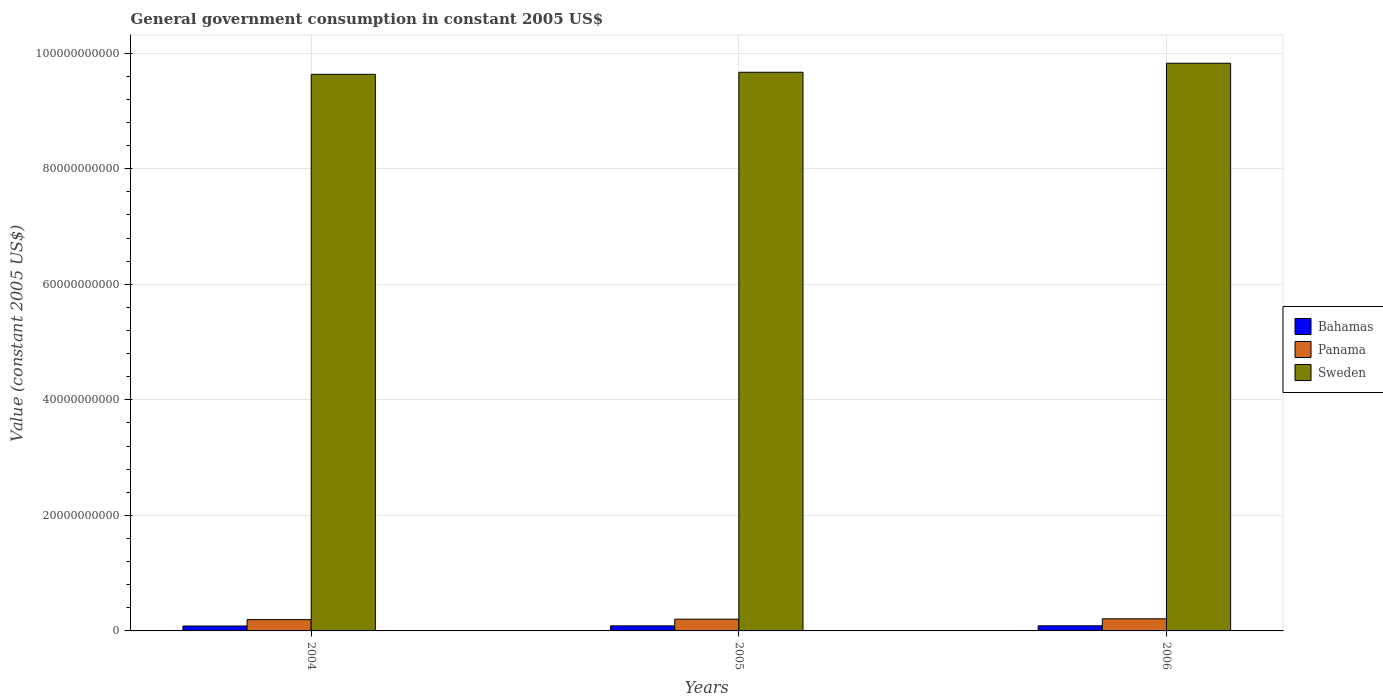How many different coloured bars are there?
Ensure brevity in your answer.  3. How many groups of bars are there?
Make the answer very short. 3. Are the number of bars on each tick of the X-axis equal?
Your answer should be compact. Yes. In how many cases, is the number of bars for a given year not equal to the number of legend labels?
Offer a very short reply. 0. What is the government conusmption in Bahamas in 2004?
Offer a terse response. 8.47e+08. Across all years, what is the maximum government conusmption in Bahamas?
Offer a terse response. 8.88e+08. Across all years, what is the minimum government conusmption in Sweden?
Provide a short and direct response. 9.63e+1. In which year was the government conusmption in Panama minimum?
Ensure brevity in your answer.  2004. What is the total government conusmption in Bahamas in the graph?
Your response must be concise. 2.61e+09. What is the difference between the government conusmption in Sweden in 2004 and that in 2005?
Keep it short and to the point. -3.58e+08. What is the difference between the government conusmption in Bahamas in 2006 and the government conusmption in Sweden in 2004?
Make the answer very short. -9.55e+1. What is the average government conusmption in Panama per year?
Your response must be concise. 2.03e+09. In the year 2005, what is the difference between the government conusmption in Sweden and government conusmption in Panama?
Give a very brief answer. 9.47e+1. In how many years, is the government conusmption in Bahamas greater than 20000000000 US$?
Offer a terse response. 0. What is the ratio of the government conusmption in Panama in 2005 to that in 2006?
Offer a terse response. 0.97. What is the difference between the highest and the second highest government conusmption in Bahamas?
Provide a short and direct response. 1.53e+07. What is the difference between the highest and the lowest government conusmption in Sweden?
Your answer should be compact. 1.92e+09. In how many years, is the government conusmption in Bahamas greater than the average government conusmption in Bahamas taken over all years?
Provide a short and direct response. 2. Is the sum of the government conusmption in Bahamas in 2005 and 2006 greater than the maximum government conusmption in Panama across all years?
Offer a terse response. No. What does the 2nd bar from the right in 2006 represents?
Make the answer very short. Panama. Is it the case that in every year, the sum of the government conusmption in Sweden and government conusmption in Bahamas is greater than the government conusmption in Panama?
Offer a terse response. Yes. How many bars are there?
Give a very brief answer. 9. How many years are there in the graph?
Make the answer very short. 3. Does the graph contain any zero values?
Your answer should be very brief. No. How many legend labels are there?
Ensure brevity in your answer.  3. What is the title of the graph?
Your answer should be compact. General government consumption in constant 2005 US$. Does "Austria" appear as one of the legend labels in the graph?
Keep it short and to the point. No. What is the label or title of the X-axis?
Ensure brevity in your answer.  Years. What is the label or title of the Y-axis?
Your answer should be compact. Value (constant 2005 US$). What is the Value (constant 2005 US$) of Bahamas in 2004?
Give a very brief answer. 8.47e+08. What is the Value (constant 2005 US$) of Panama in 2004?
Make the answer very short. 1.95e+09. What is the Value (constant 2005 US$) of Sweden in 2004?
Make the answer very short. 9.63e+1. What is the Value (constant 2005 US$) of Bahamas in 2005?
Give a very brief answer. 8.73e+08. What is the Value (constant 2005 US$) of Panama in 2005?
Your answer should be compact. 2.03e+09. What is the Value (constant 2005 US$) of Sweden in 2005?
Your answer should be compact. 9.67e+1. What is the Value (constant 2005 US$) in Bahamas in 2006?
Provide a succinct answer. 8.88e+08. What is the Value (constant 2005 US$) of Panama in 2006?
Make the answer very short. 2.10e+09. What is the Value (constant 2005 US$) in Sweden in 2006?
Ensure brevity in your answer.  9.83e+1. Across all years, what is the maximum Value (constant 2005 US$) in Bahamas?
Your answer should be very brief. 8.88e+08. Across all years, what is the maximum Value (constant 2005 US$) of Panama?
Your answer should be very brief. 2.10e+09. Across all years, what is the maximum Value (constant 2005 US$) of Sweden?
Give a very brief answer. 9.83e+1. Across all years, what is the minimum Value (constant 2005 US$) of Bahamas?
Your answer should be compact. 8.47e+08. Across all years, what is the minimum Value (constant 2005 US$) of Panama?
Offer a very short reply. 1.95e+09. Across all years, what is the minimum Value (constant 2005 US$) in Sweden?
Make the answer very short. 9.63e+1. What is the total Value (constant 2005 US$) of Bahamas in the graph?
Provide a succinct answer. 2.61e+09. What is the total Value (constant 2005 US$) in Panama in the graph?
Offer a terse response. 6.08e+09. What is the total Value (constant 2005 US$) in Sweden in the graph?
Give a very brief answer. 2.91e+11. What is the difference between the Value (constant 2005 US$) in Bahamas in 2004 and that in 2005?
Ensure brevity in your answer.  -2.65e+07. What is the difference between the Value (constant 2005 US$) of Panama in 2004 and that in 2005?
Give a very brief answer. -8.10e+07. What is the difference between the Value (constant 2005 US$) of Sweden in 2004 and that in 2005?
Make the answer very short. -3.58e+08. What is the difference between the Value (constant 2005 US$) of Bahamas in 2004 and that in 2006?
Your response must be concise. -4.18e+07. What is the difference between the Value (constant 2005 US$) in Panama in 2004 and that in 2006?
Make the answer very short. -1.44e+08. What is the difference between the Value (constant 2005 US$) of Sweden in 2004 and that in 2006?
Provide a succinct answer. -1.92e+09. What is the difference between the Value (constant 2005 US$) in Bahamas in 2005 and that in 2006?
Make the answer very short. -1.53e+07. What is the difference between the Value (constant 2005 US$) in Panama in 2005 and that in 2006?
Make the answer very short. -6.29e+07. What is the difference between the Value (constant 2005 US$) of Sweden in 2005 and that in 2006?
Your answer should be compact. -1.56e+09. What is the difference between the Value (constant 2005 US$) of Bahamas in 2004 and the Value (constant 2005 US$) of Panama in 2005?
Offer a terse response. -1.19e+09. What is the difference between the Value (constant 2005 US$) of Bahamas in 2004 and the Value (constant 2005 US$) of Sweden in 2005?
Offer a terse response. -9.59e+1. What is the difference between the Value (constant 2005 US$) of Panama in 2004 and the Value (constant 2005 US$) of Sweden in 2005?
Make the answer very short. -9.47e+1. What is the difference between the Value (constant 2005 US$) in Bahamas in 2004 and the Value (constant 2005 US$) in Panama in 2006?
Give a very brief answer. -1.25e+09. What is the difference between the Value (constant 2005 US$) in Bahamas in 2004 and the Value (constant 2005 US$) in Sweden in 2006?
Provide a short and direct response. -9.74e+1. What is the difference between the Value (constant 2005 US$) in Panama in 2004 and the Value (constant 2005 US$) in Sweden in 2006?
Your response must be concise. -9.63e+1. What is the difference between the Value (constant 2005 US$) of Bahamas in 2005 and the Value (constant 2005 US$) of Panama in 2006?
Ensure brevity in your answer.  -1.22e+09. What is the difference between the Value (constant 2005 US$) in Bahamas in 2005 and the Value (constant 2005 US$) in Sweden in 2006?
Make the answer very short. -9.74e+1. What is the difference between the Value (constant 2005 US$) in Panama in 2005 and the Value (constant 2005 US$) in Sweden in 2006?
Offer a terse response. -9.62e+1. What is the average Value (constant 2005 US$) in Bahamas per year?
Offer a terse response. 8.69e+08. What is the average Value (constant 2005 US$) in Panama per year?
Your answer should be very brief. 2.03e+09. What is the average Value (constant 2005 US$) in Sweden per year?
Provide a short and direct response. 9.71e+1. In the year 2004, what is the difference between the Value (constant 2005 US$) of Bahamas and Value (constant 2005 US$) of Panama?
Ensure brevity in your answer.  -1.11e+09. In the year 2004, what is the difference between the Value (constant 2005 US$) of Bahamas and Value (constant 2005 US$) of Sweden?
Keep it short and to the point. -9.55e+1. In the year 2004, what is the difference between the Value (constant 2005 US$) of Panama and Value (constant 2005 US$) of Sweden?
Make the answer very short. -9.44e+1. In the year 2005, what is the difference between the Value (constant 2005 US$) in Bahamas and Value (constant 2005 US$) in Panama?
Provide a short and direct response. -1.16e+09. In the year 2005, what is the difference between the Value (constant 2005 US$) of Bahamas and Value (constant 2005 US$) of Sweden?
Offer a very short reply. -9.58e+1. In the year 2005, what is the difference between the Value (constant 2005 US$) in Panama and Value (constant 2005 US$) in Sweden?
Provide a short and direct response. -9.47e+1. In the year 2006, what is the difference between the Value (constant 2005 US$) of Bahamas and Value (constant 2005 US$) of Panama?
Offer a very short reply. -1.21e+09. In the year 2006, what is the difference between the Value (constant 2005 US$) in Bahamas and Value (constant 2005 US$) in Sweden?
Ensure brevity in your answer.  -9.74e+1. In the year 2006, what is the difference between the Value (constant 2005 US$) of Panama and Value (constant 2005 US$) of Sweden?
Give a very brief answer. -9.62e+1. What is the ratio of the Value (constant 2005 US$) of Bahamas in 2004 to that in 2005?
Provide a succinct answer. 0.97. What is the ratio of the Value (constant 2005 US$) in Panama in 2004 to that in 2005?
Offer a terse response. 0.96. What is the ratio of the Value (constant 2005 US$) of Sweden in 2004 to that in 2005?
Ensure brevity in your answer.  1. What is the ratio of the Value (constant 2005 US$) of Bahamas in 2004 to that in 2006?
Give a very brief answer. 0.95. What is the ratio of the Value (constant 2005 US$) of Panama in 2004 to that in 2006?
Offer a terse response. 0.93. What is the ratio of the Value (constant 2005 US$) of Sweden in 2004 to that in 2006?
Provide a short and direct response. 0.98. What is the ratio of the Value (constant 2005 US$) in Bahamas in 2005 to that in 2006?
Your answer should be compact. 0.98. What is the ratio of the Value (constant 2005 US$) in Panama in 2005 to that in 2006?
Provide a succinct answer. 0.97. What is the ratio of the Value (constant 2005 US$) of Sweden in 2005 to that in 2006?
Offer a very short reply. 0.98. What is the difference between the highest and the second highest Value (constant 2005 US$) of Bahamas?
Give a very brief answer. 1.53e+07. What is the difference between the highest and the second highest Value (constant 2005 US$) in Panama?
Offer a terse response. 6.29e+07. What is the difference between the highest and the second highest Value (constant 2005 US$) of Sweden?
Provide a short and direct response. 1.56e+09. What is the difference between the highest and the lowest Value (constant 2005 US$) of Bahamas?
Offer a terse response. 4.18e+07. What is the difference between the highest and the lowest Value (constant 2005 US$) in Panama?
Provide a succinct answer. 1.44e+08. What is the difference between the highest and the lowest Value (constant 2005 US$) of Sweden?
Ensure brevity in your answer.  1.92e+09. 